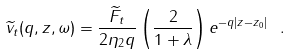<formula> <loc_0><loc_0><loc_500><loc_500>\widetilde { v } _ { t } ( q , z , \omega ) = \frac { \widetilde { F } _ { t } } { 2 \eta _ { 2 } q } \left ( \frac { 2 } { 1 + \lambda } \right ) e ^ { - q | z - z _ { 0 } | } \ .</formula> 